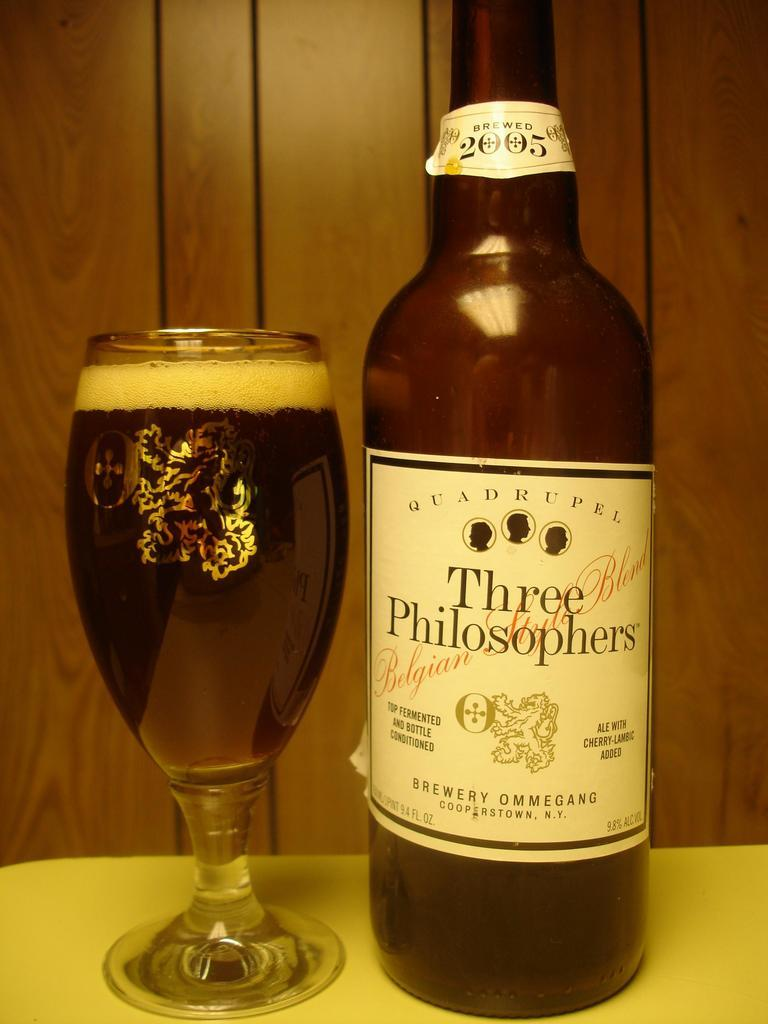<image>
Offer a succinct explanation of the picture presented. bottle of three philosophers ale next to a full glass with wood paneling behind it 